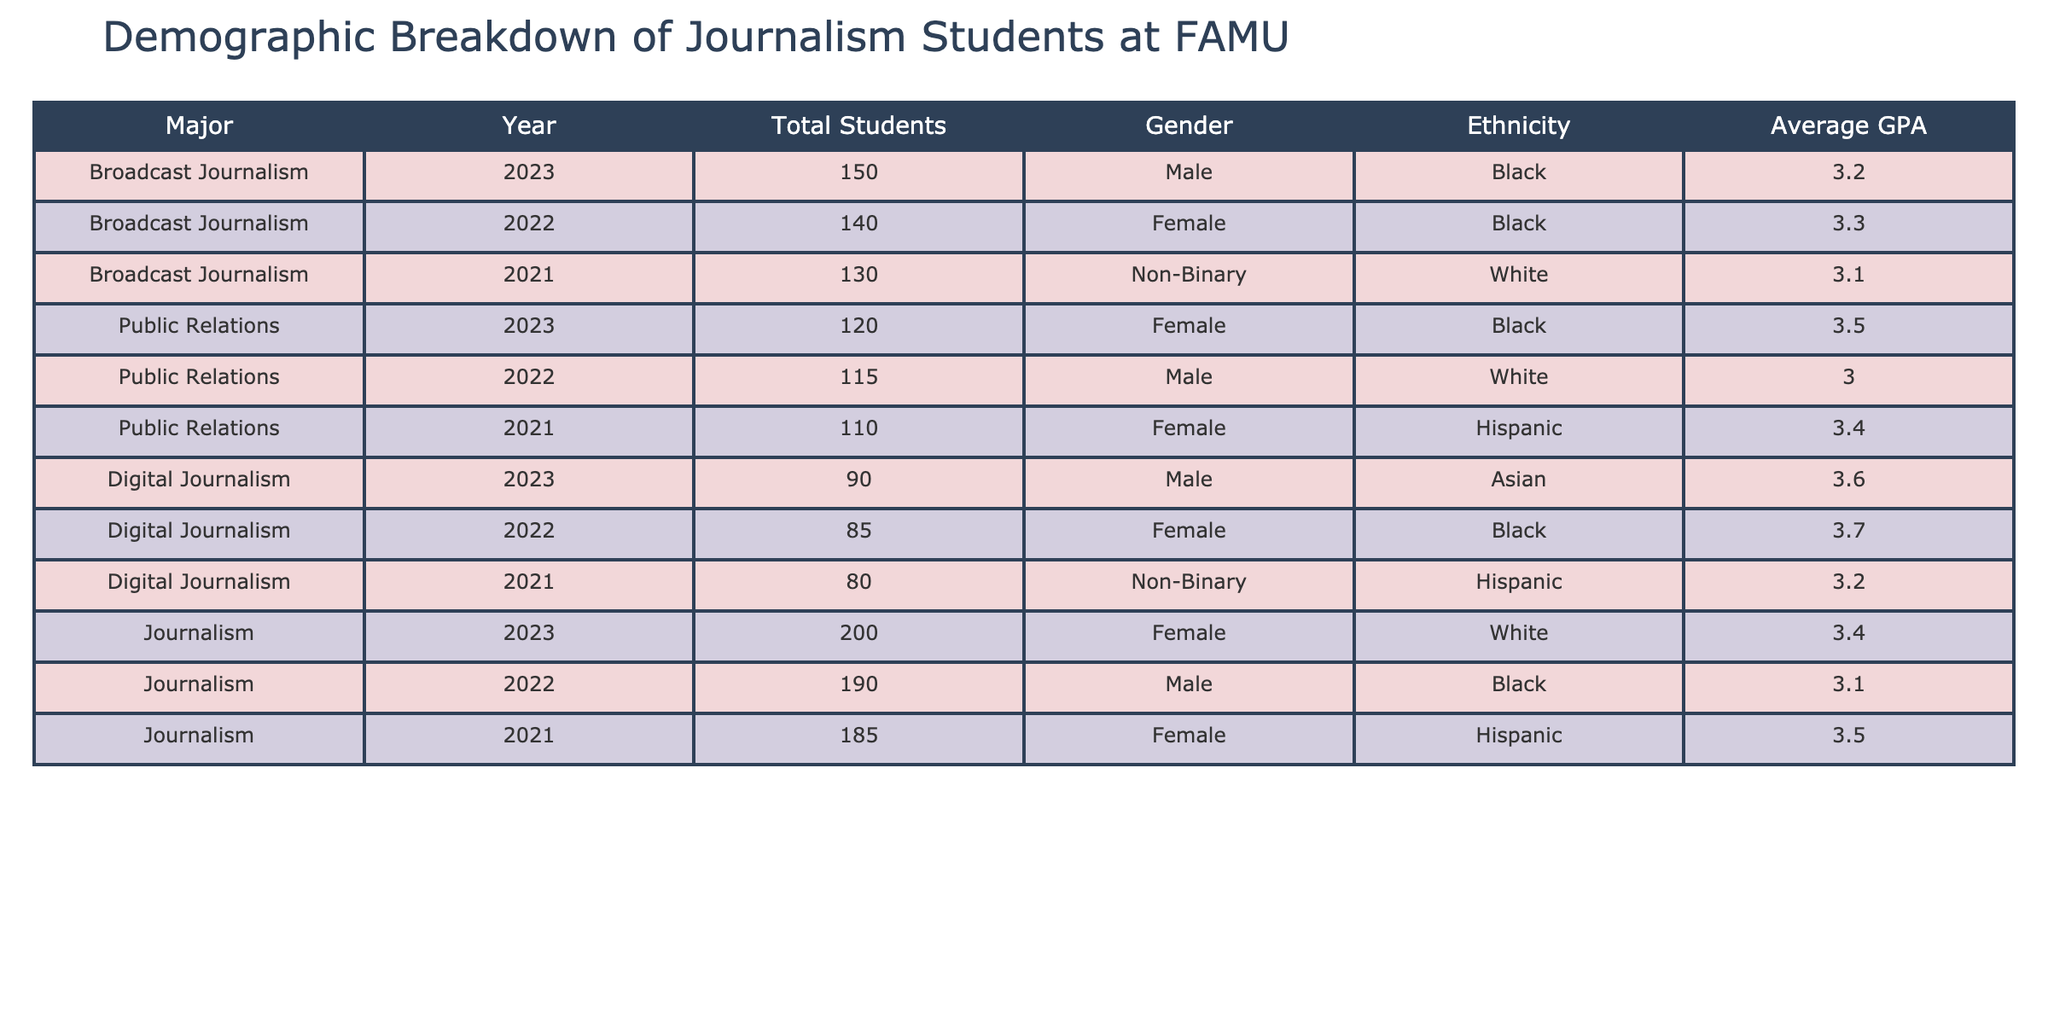What is the total number of Digital Journalism students in 2023? The table shows that the number of Digital Journalism students in 2023 is listed under the "Total Students" column, which indicates there are 90 students for that year.
Answer: 90 How many Female students are there in Broadcast Journalism across the three years? To find the total number of Female Broadcast Journalism students, we add the numbers from 2022 (140) and the female from 2021 (0) (not listed), giving us 140 + 0 = 140.
Answer: 140 What is the highest average GPA among Public Relations students? By examining the Average GPA for Public Relations, we find the values for the three years: 3.0 (2022), 3.4 (2021), and 3.5 (2023). The highest value among these is 3.5.
Answer: 3.5 Is there a Non-Binary student in Journalism for the years listed? The table must be searched through the Gender column for Journalism from all years. There are no entries under "Non-Binary" for Journalism, confirming the answer is no.
Answer: No What is the difference in total students between Journalism and Public Relations in 2023? In 2023, Journalism has 200 students, and Public Relations has 120 students. The difference is 200 - 120 = 80 students.
Answer: 80 Which major has the highest average GPA in 2023? Look at the Average GPA for each major in 2023: Broadcast Journalism (3.2), Public Relations (3.5), Digital Journalism (3.6), and Journalism (3.4). The highest is Digital Journalism at 3.6.
Answer: Digital Journalism How many students of Hispanic ethnicity are there across all majors in 2021? In 2021, the table shows Hispanic students in Public Relations (110) and Journalism (185). Adding these, we find 110 + 185 = 295 total students of Hispanic ethnicity.
Answer: 295 What percentage of Broadcast Journalism students are Male in 2022? In 2022, there are 140 total Broadcast Journalism students with 0 recorded male students. To find the percentage, we can say (0 / 140) * 100 = 0%.
Answer: 0% How many years show a decrease in total students for Journalism? Looking at the total students for Journalism: 185 (2021) to 190 (2022) and 200 (2023), we see an increase each year, which means there are no years of decrease in enrollment.
Answer: 0 years Is there an increase in the total number of students in Public Relations from 2021 to 2023? Checking the total for Public Relations, we see 110 students in 2021, 115 in 2022, and 120 in 2023. The values show an increase from 110 to 120 over the years.
Answer: Yes 